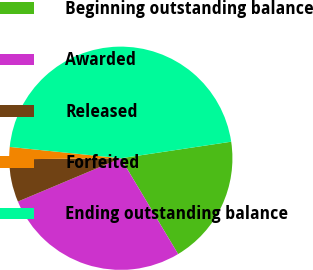Convert chart. <chart><loc_0><loc_0><loc_500><loc_500><pie_chart><fcel>Beginning outstanding balance<fcel>Awarded<fcel>Released<fcel>Forfeited<fcel>Ending outstanding balance<nl><fcel>18.79%<fcel>27.24%<fcel>6.19%<fcel>1.77%<fcel>46.01%<nl></chart> 